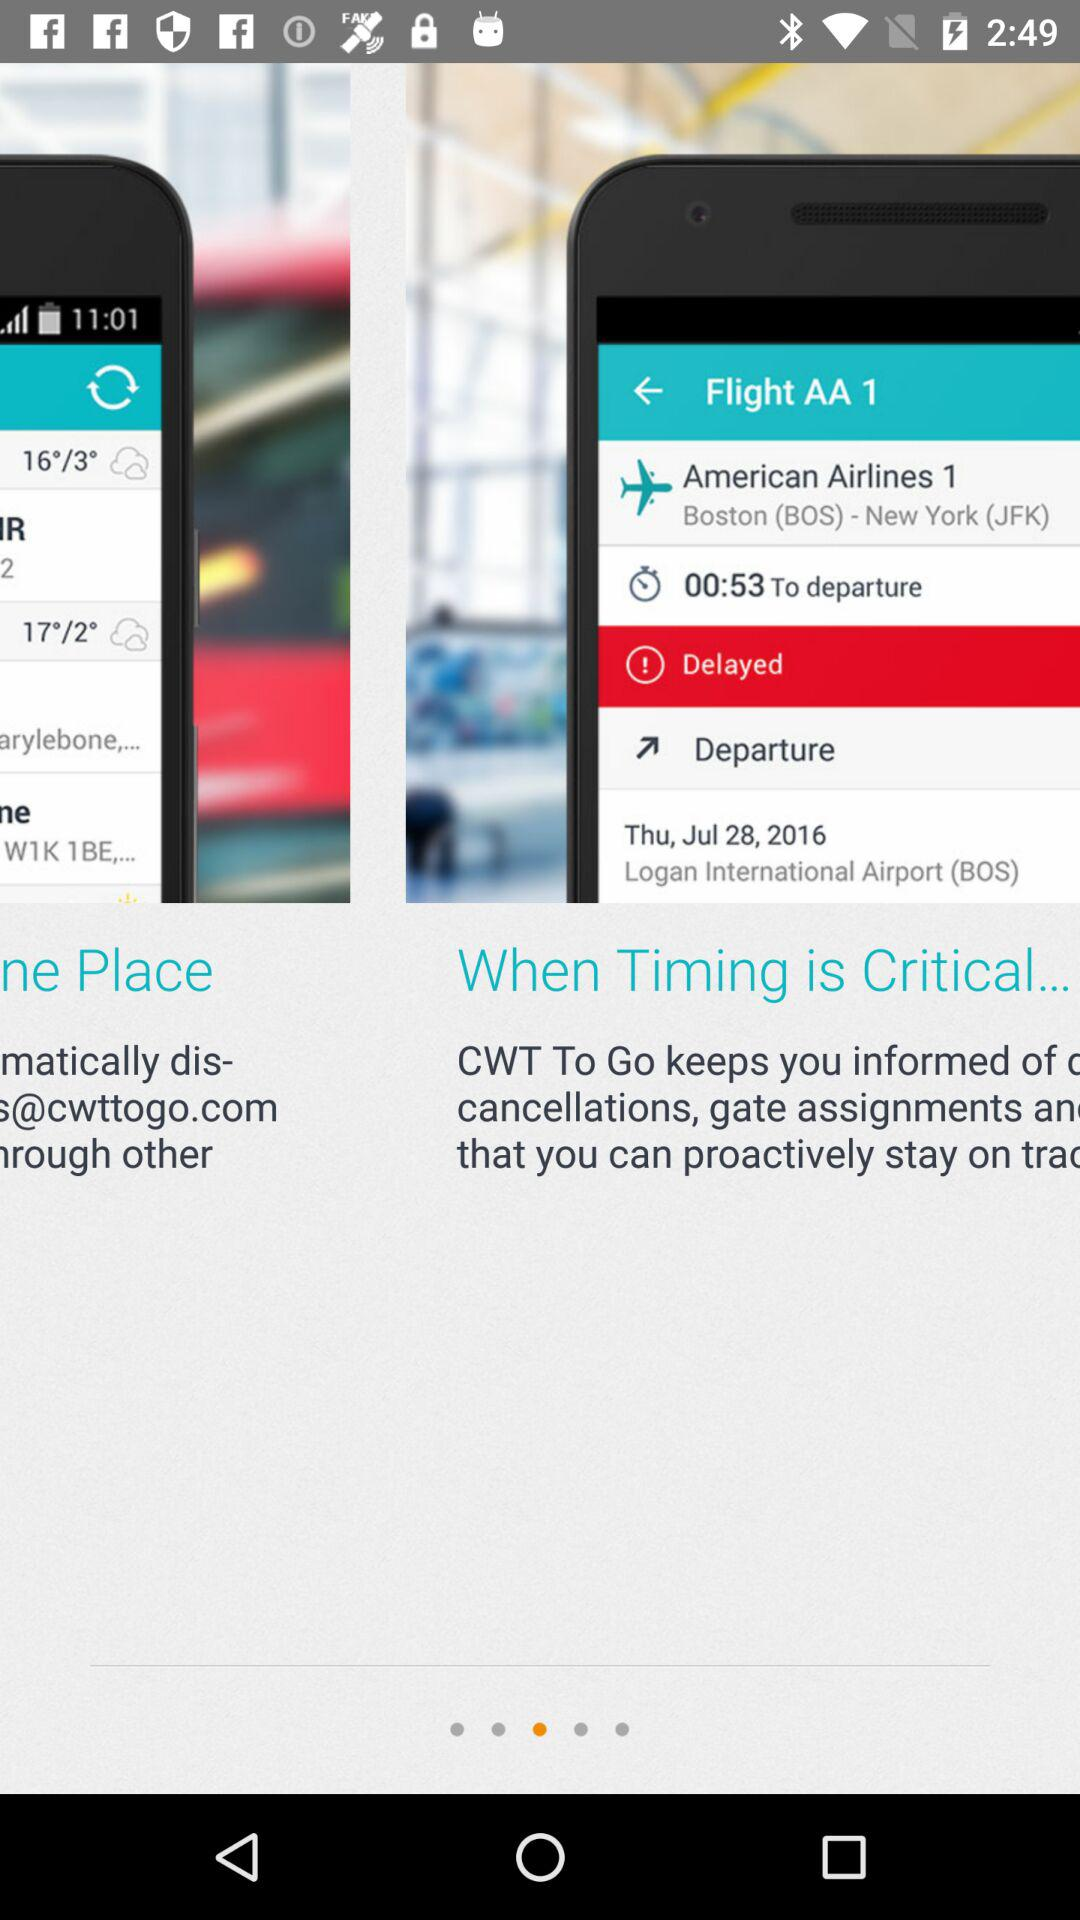How many minutes later is the flight scheduled to depart than it is currently?
Answer the question using a single word or phrase. 53 